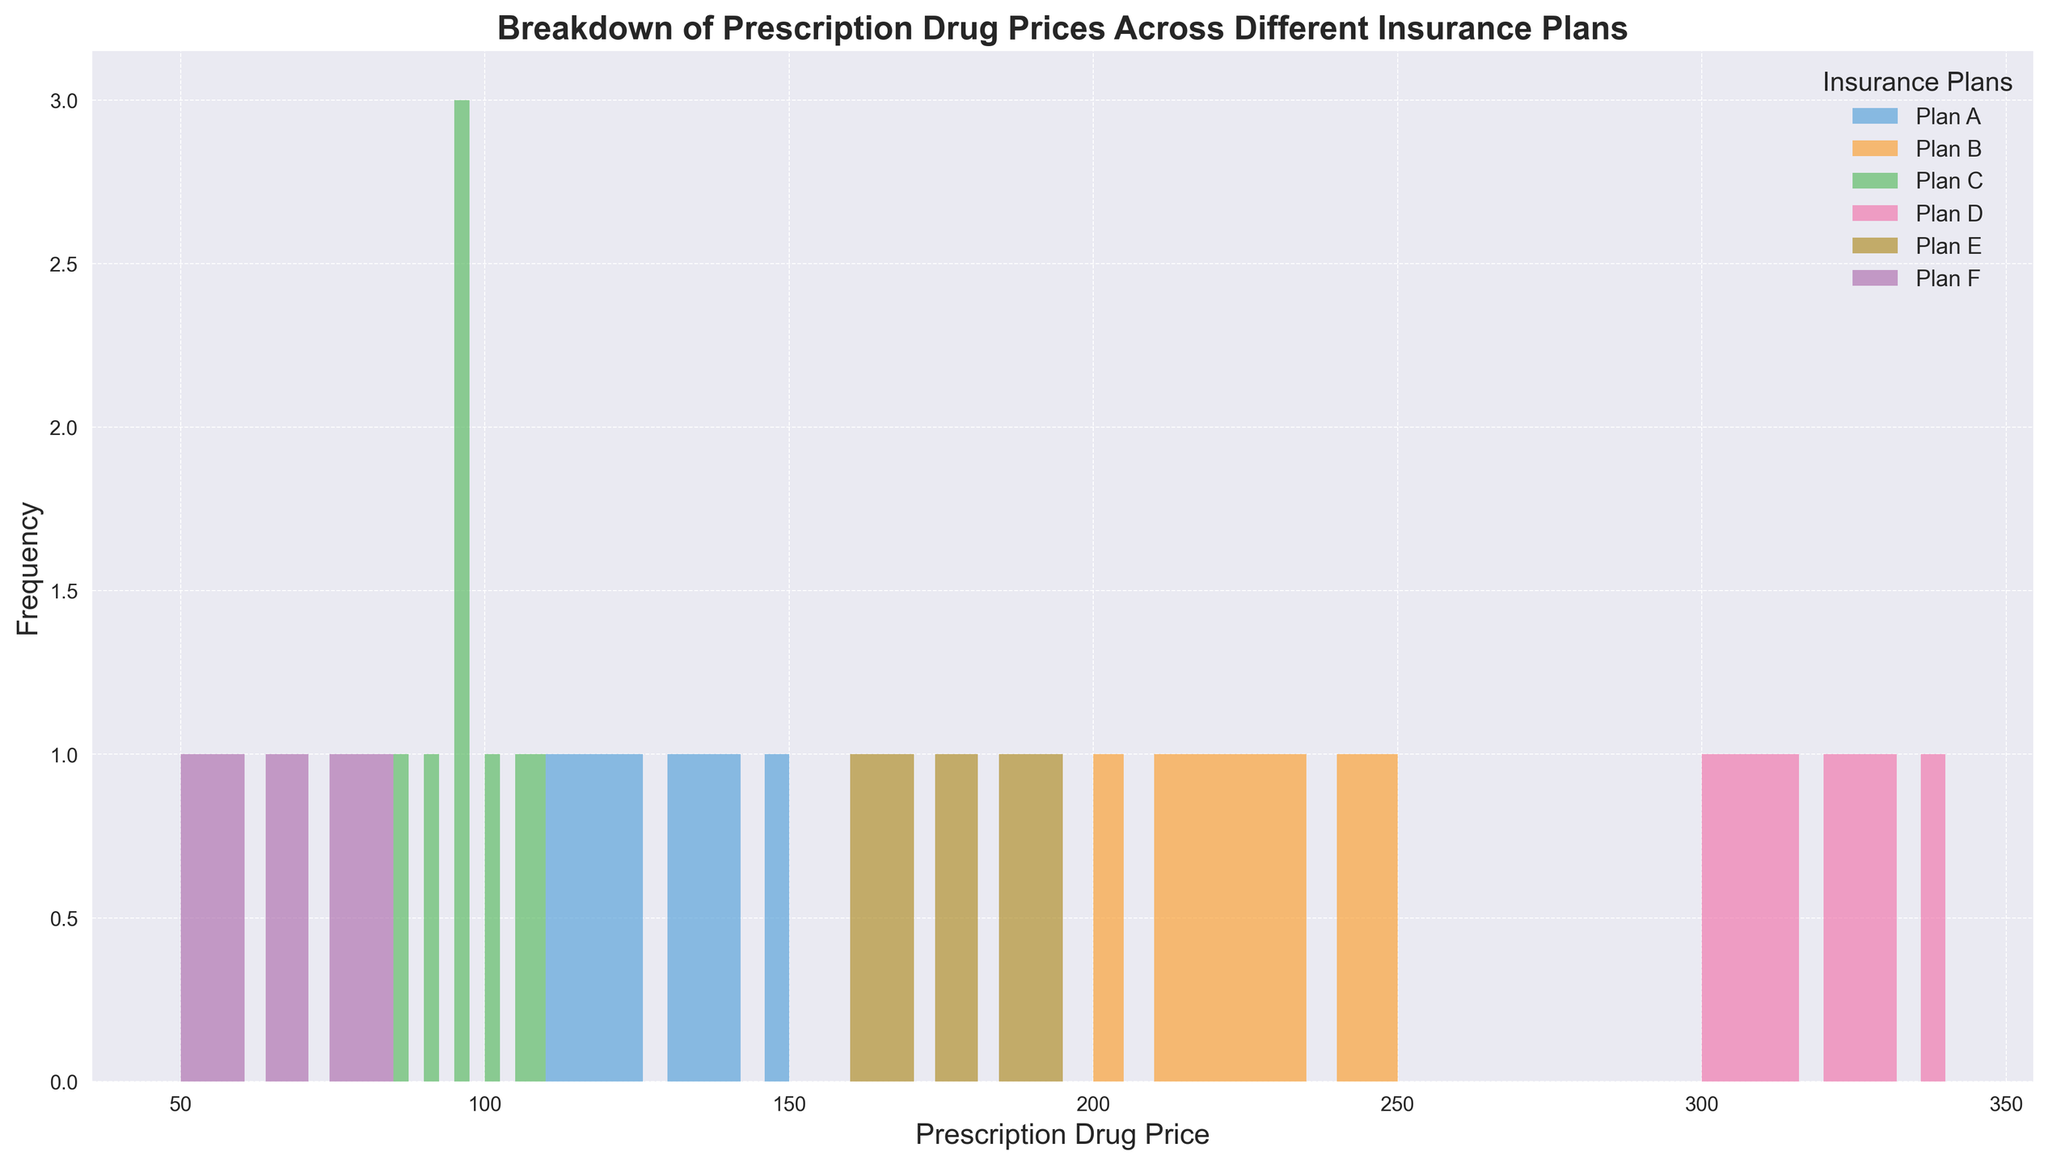What is the most frequent price range for Plan A? Examine the histogram bars corresponding to Plan A and identify which bar is the tallest. The height of the bar indicates the frequency of prices falling within that range.
Answer: 110-120 Which plan has the highest frequency of low prescription drug prices? Look at the leftmost parts of the histograms for each plan (i.e., the lower price ranges) and identify which plan's histogram bars extend the highest.
Answer: Plan F How does the median price of Plan D compare to that of Plan B? The median price is the middle value in a list of numbers sorted in ascending order. Compare the median on the histogram of Plan D (higher prices) to Plan B (lower prices).
Answer: Plan D > Plan B Which insurance plan has the widest range of prescription drug prices? Determine which histogram spans the greatest breadth on the x-axis, indicating the range from the minimum to the maximum price.
Answer: Plan D How many plans have a highest price range above $250? Look at the histogram data for each plan and count how many have bars in the region above $250 on the x-axis.
Answer: 2 plans (Plan D and Plan B) What insurance plan has the narrowest range of prescription drug prices? Identify the histogram with the smallest spread on the x-axis, meaning the smallest difference between the lowest and highest prices.
Answer: Plan F How do the frequency distributions of prescription drug prices for Plan C and Plan E differ? Compare the shapes and locations of the histogram bars for Plan C and Plan E. Plan C will show prices clustered around lower values while Plan E will show prices in a higher range.
Answer: Plan C is lower and more concentrated, Plan E is higher and more spread out Which insurance plan has the most variability in prescription drug prices? Assess which histogram has the most even distribution of heights across multiple bars, indicating high variability.
Answer: Plan D Between which two plans is the difference in median prescription drug prices the greatest? Identifying the middle values of each distribution, compare all pairs of plans to find the maximum difference in their median values.
Answer: Plan D and Plan F 